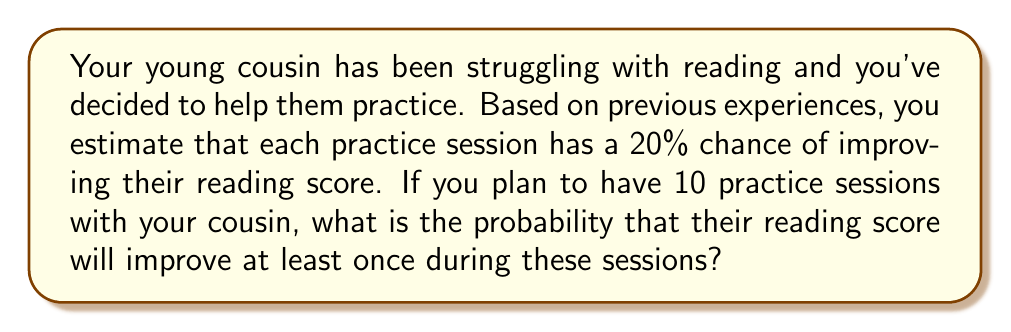Teach me how to tackle this problem. Let's approach this step-by-step:

1) First, let's define our events:
   - Success: The reading score improves in a session
   - Failure: The reading score doesn't improve in a session

2) We know that:
   - P(Success) = 0.20
   - P(Failure) = 1 - 0.20 = 0.80

3) We want to find the probability of at least one success in 10 trials. It's easier to calculate the probability of no successes and then subtract from 1.

4) The probability of no successes in 10 trials is:
   $$(0.80)^{10} = 0.1074$$

5) Therefore, the probability of at least one success is:
   $$1 - (0.80)^{10} = 1 - 0.1074 = 0.8926$$

6) We can also solve this using the binomial probability formula:

   $$P(X \geq 1) = 1 - P(X = 0) = 1 - \binom{10}{0}(0.20)^0(0.80)^{10} = 0.8926$$

   Where $X$ is the number of successful improvements.

So, there is approximately a 89.26% chance that your cousin's reading score will improve at least once during the 10 practice sessions.
Answer: 0.8926 or 89.26% 